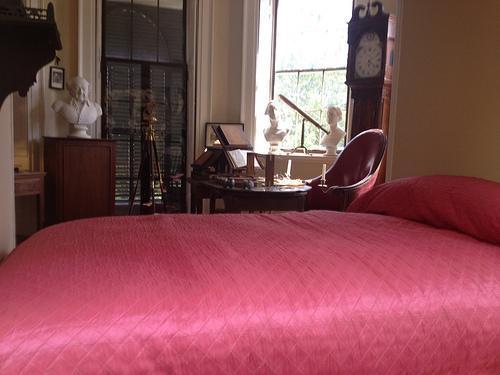How many bust statues are visible?
Give a very brief answer. 3. How many beds are visible?
Give a very brief answer. 1. 